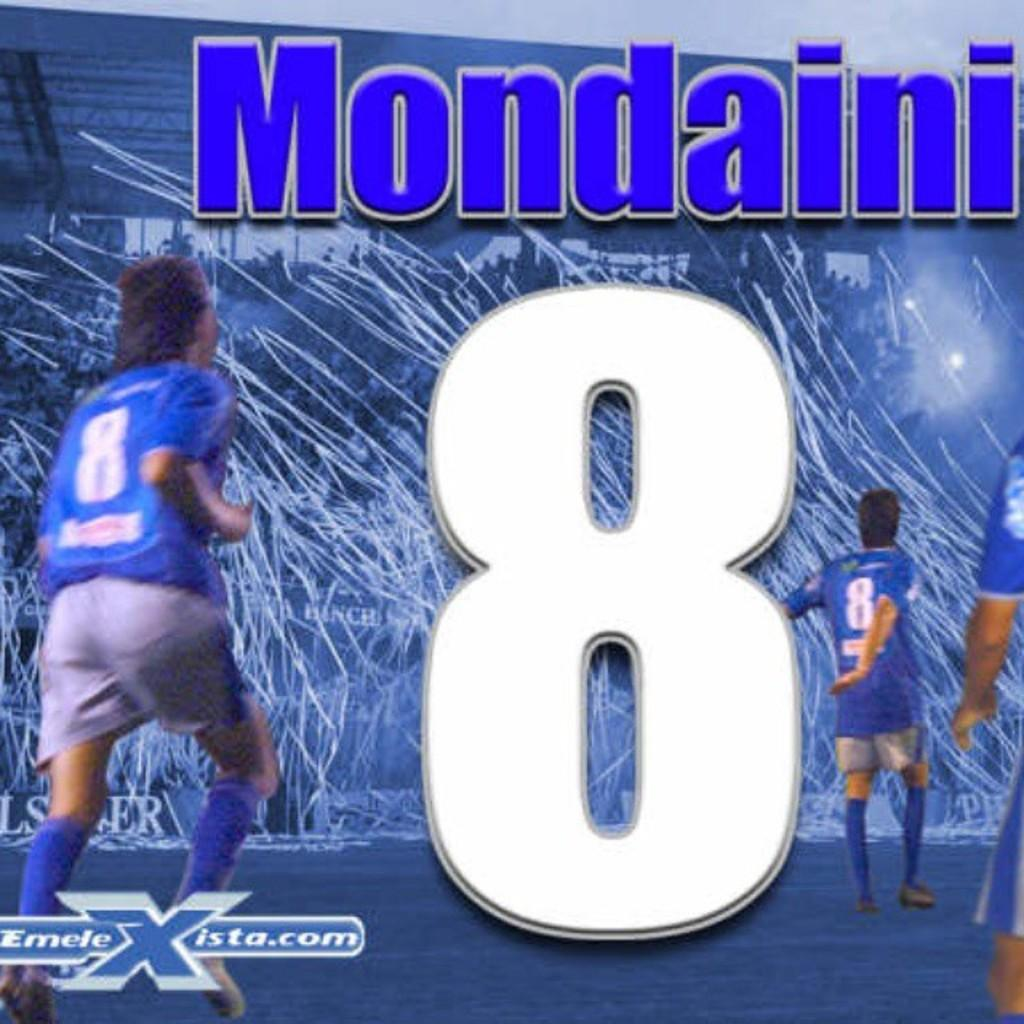<image>
Relay a brief, clear account of the picture shown. An illustrated soccer scene says Mondaini at the top. 